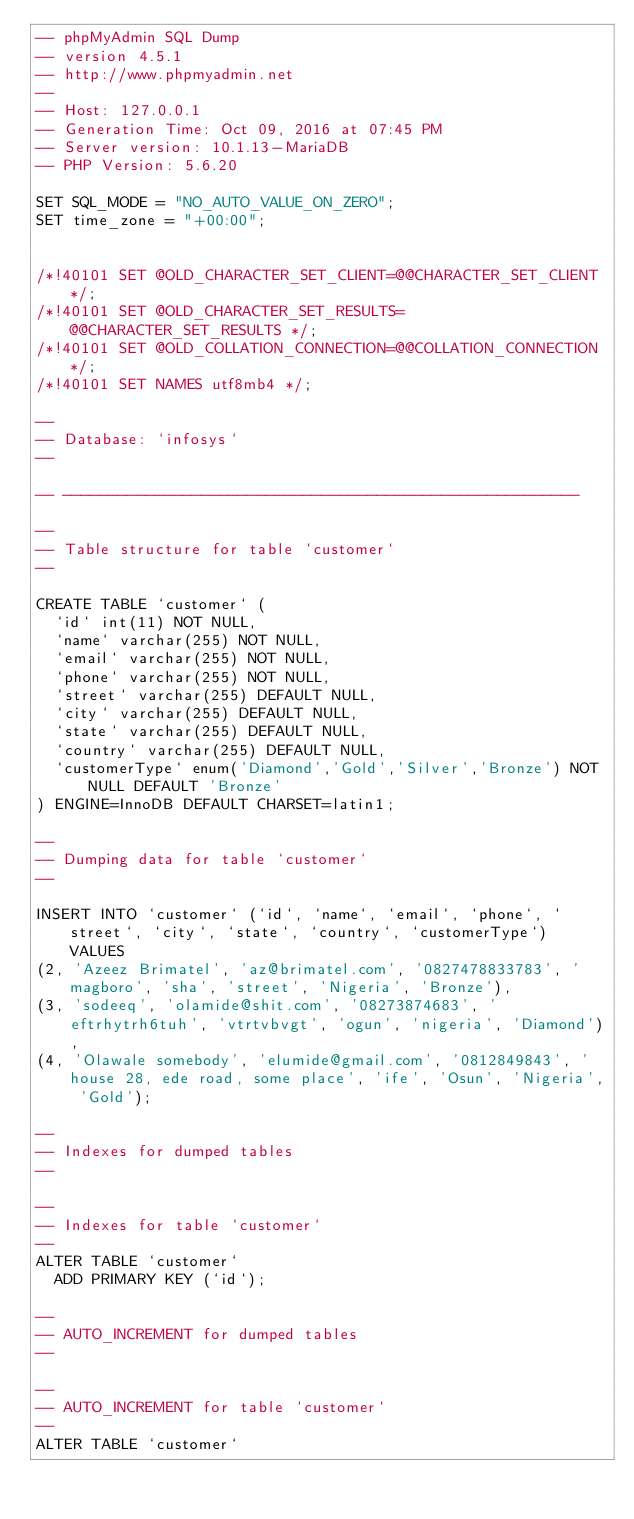<code> <loc_0><loc_0><loc_500><loc_500><_SQL_>-- phpMyAdmin SQL Dump
-- version 4.5.1
-- http://www.phpmyadmin.net
--
-- Host: 127.0.0.1
-- Generation Time: Oct 09, 2016 at 07:45 PM
-- Server version: 10.1.13-MariaDB
-- PHP Version: 5.6.20

SET SQL_MODE = "NO_AUTO_VALUE_ON_ZERO";
SET time_zone = "+00:00";


/*!40101 SET @OLD_CHARACTER_SET_CLIENT=@@CHARACTER_SET_CLIENT */;
/*!40101 SET @OLD_CHARACTER_SET_RESULTS=@@CHARACTER_SET_RESULTS */;
/*!40101 SET @OLD_COLLATION_CONNECTION=@@COLLATION_CONNECTION */;
/*!40101 SET NAMES utf8mb4 */;

--
-- Database: `infosys`
--

-- --------------------------------------------------------

--
-- Table structure for table `customer`
--

CREATE TABLE `customer` (
  `id` int(11) NOT NULL,
  `name` varchar(255) NOT NULL,
  `email` varchar(255) NOT NULL,
  `phone` varchar(255) NOT NULL,
  `street` varchar(255) DEFAULT NULL,
  `city` varchar(255) DEFAULT NULL,
  `state` varchar(255) DEFAULT NULL,
  `country` varchar(255) DEFAULT NULL,
  `customerType` enum('Diamond','Gold','Silver','Bronze') NOT NULL DEFAULT 'Bronze'
) ENGINE=InnoDB DEFAULT CHARSET=latin1;

--
-- Dumping data for table `customer`
--

INSERT INTO `customer` (`id`, `name`, `email`, `phone`, `street`, `city`, `state`, `country`, `customerType`) VALUES
(2, 'Azeez Brimatel', 'az@brimatel.com', '0827478833783', 'magboro', 'sha', 'street', 'Nigeria', 'Bronze'),
(3, 'sodeeq', 'olamide@shit.com', '08273874683', 'eftrhytrh6tuh', 'vtrtvbvgt', 'ogun', 'nigeria', 'Diamond'),
(4, 'Olawale somebody', 'elumide@gmail.com', '0812849843', 'house 28, ede road, some place', 'ife', 'Osun', 'Nigeria', 'Gold');

--
-- Indexes for dumped tables
--

--
-- Indexes for table `customer`
--
ALTER TABLE `customer`
  ADD PRIMARY KEY (`id`);

--
-- AUTO_INCREMENT for dumped tables
--

--
-- AUTO_INCREMENT for table `customer`
--
ALTER TABLE `customer`</code> 